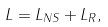<formula> <loc_0><loc_0><loc_500><loc_500>L = L _ { N S } + L _ { R } ,</formula> 